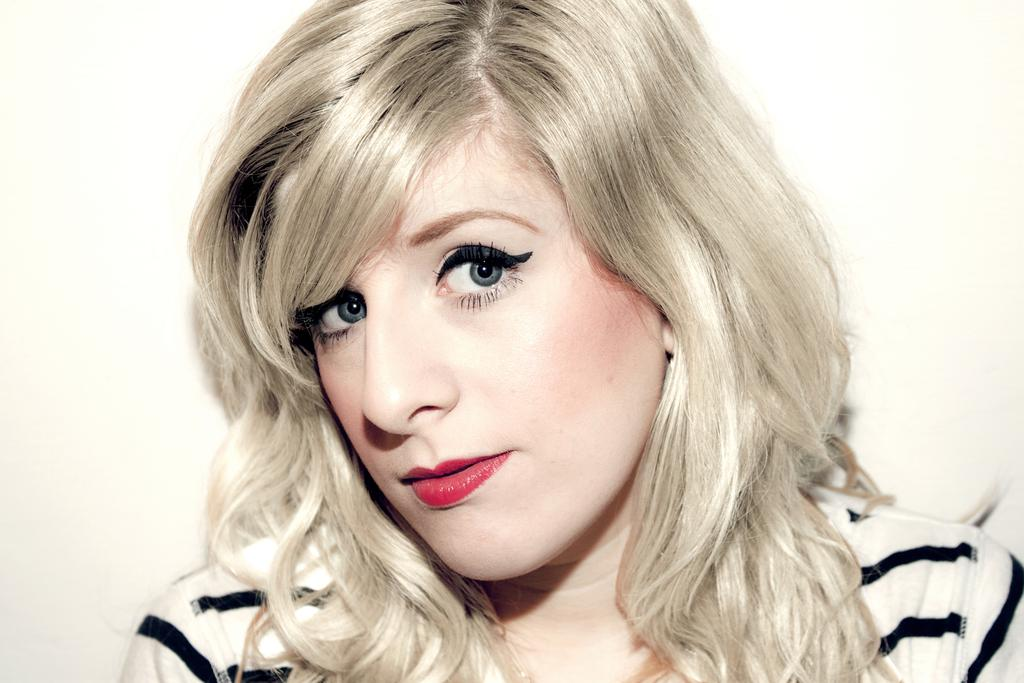Who is the main subject in the image? There is a lady in the center of the image. What can be seen behind the lady? There is a wall in the background of the image. What type of underwear is the lady wearing in the image? There is no information about the lady's underwear in the image, so it cannot be determined. 